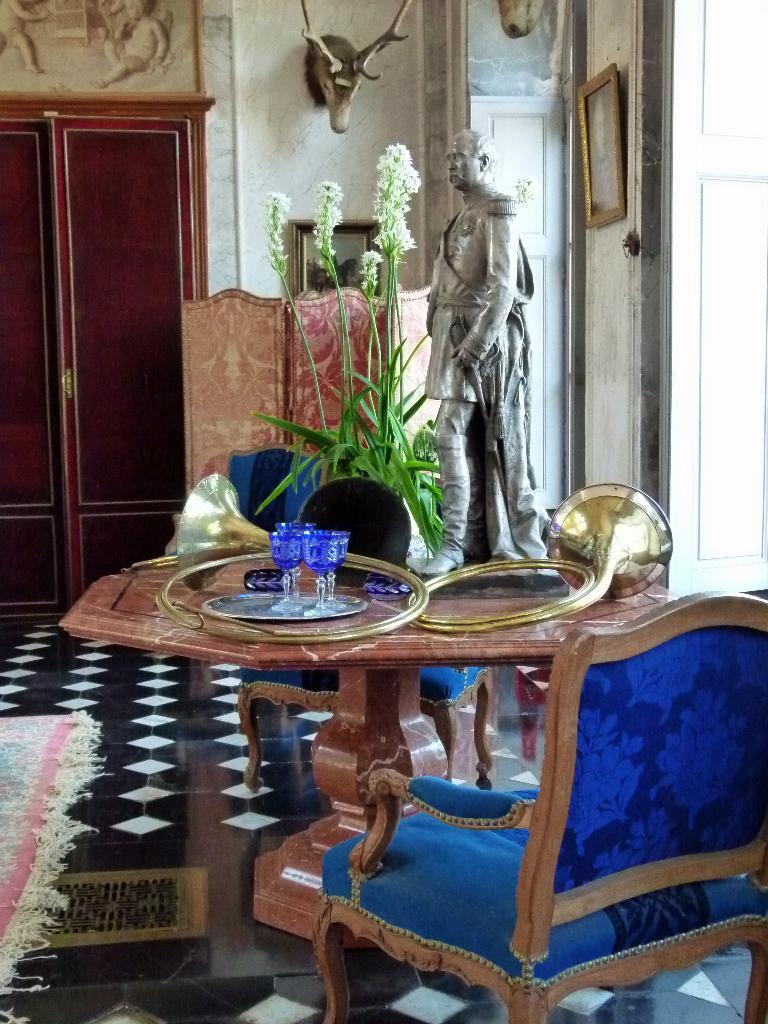How would you summarize this image in a sentence or two? In this image we can see a sculpture of a person. There are few photos and objects on the wall. There are few objects on the table. There is a chair at the right side of the image. There is a cupboard in the image. There is a mat on the floor. 